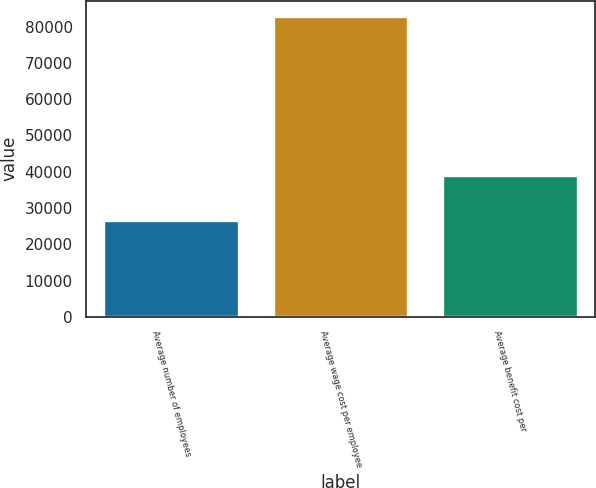Convert chart to OTSL. <chart><loc_0><loc_0><loc_500><loc_500><bar_chart><fcel>Average number of employees<fcel>Average wage cost per employee<fcel>Average benefit cost per<nl><fcel>26662<fcel>83000<fcel>39000<nl></chart> 